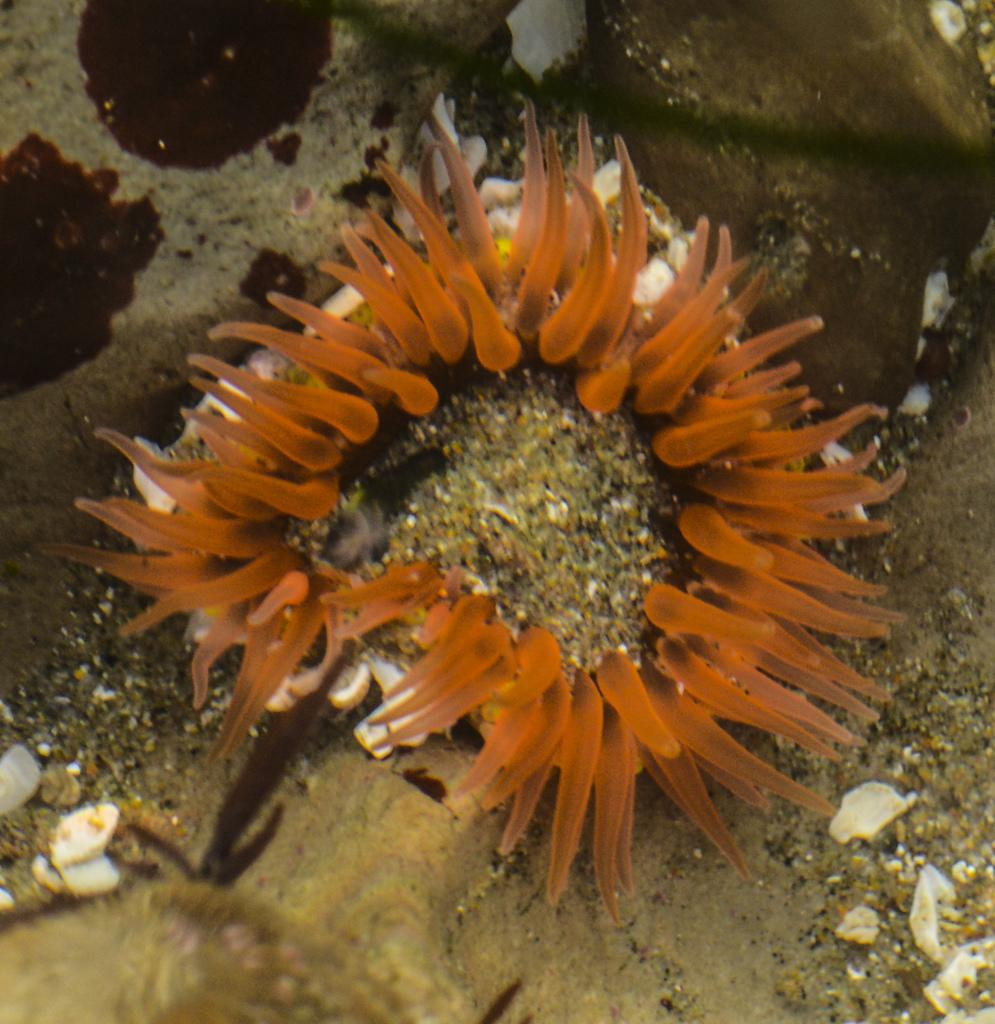What type of animal is in the image? There is an aquatic animal in the image. What color is the aquatic animal? The aquatic animal is orange in color. What can be seen on the sand in the image? There are white color objects on the sand in the image. What type of apparel is the aquatic animal wearing in the image? There is no apparel present on the aquatic animal in the image. What type of grain can be seen growing on the sand in the image? There is no grain visible in the image; it features an orange aquatic animal and white objects on the sand. 